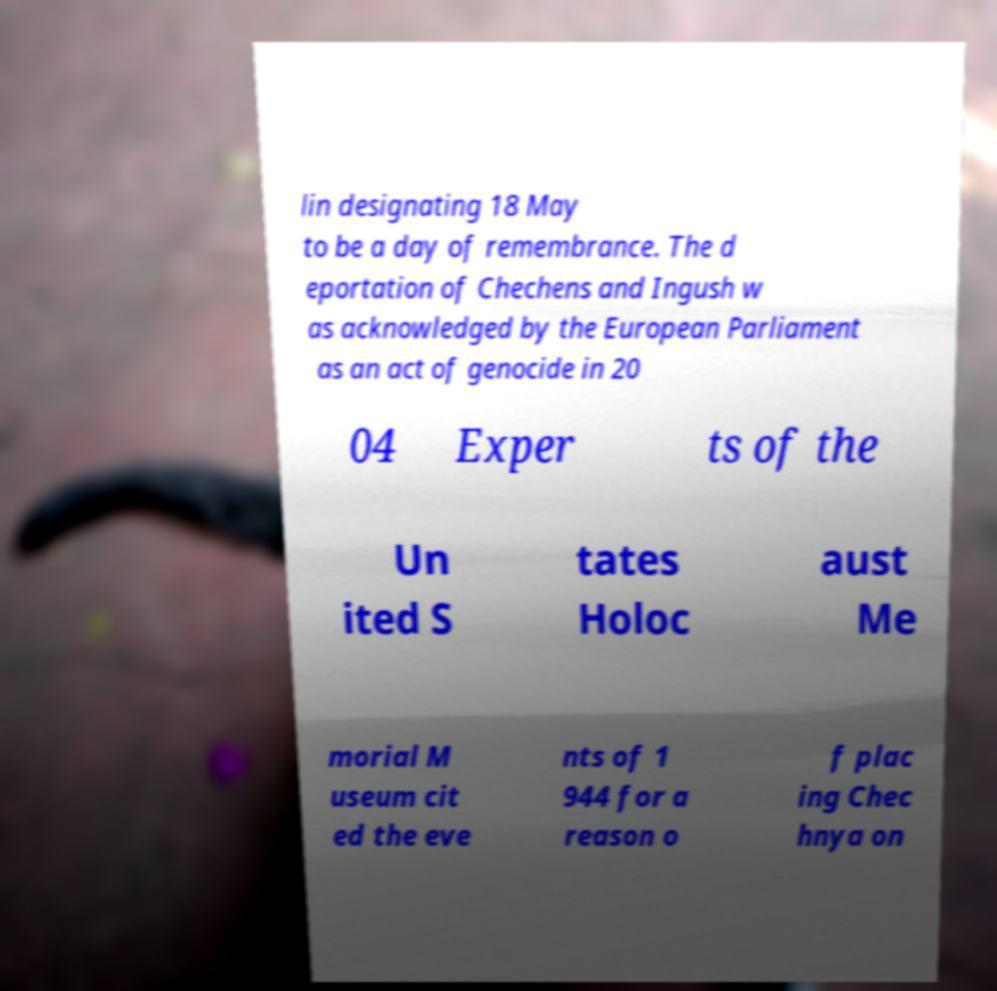I need the written content from this picture converted into text. Can you do that? lin designating 18 May to be a day of remembrance. The d eportation of Chechens and Ingush w as acknowledged by the European Parliament as an act of genocide in 20 04 Exper ts of the Un ited S tates Holoc aust Me morial M useum cit ed the eve nts of 1 944 for a reason o f plac ing Chec hnya on 